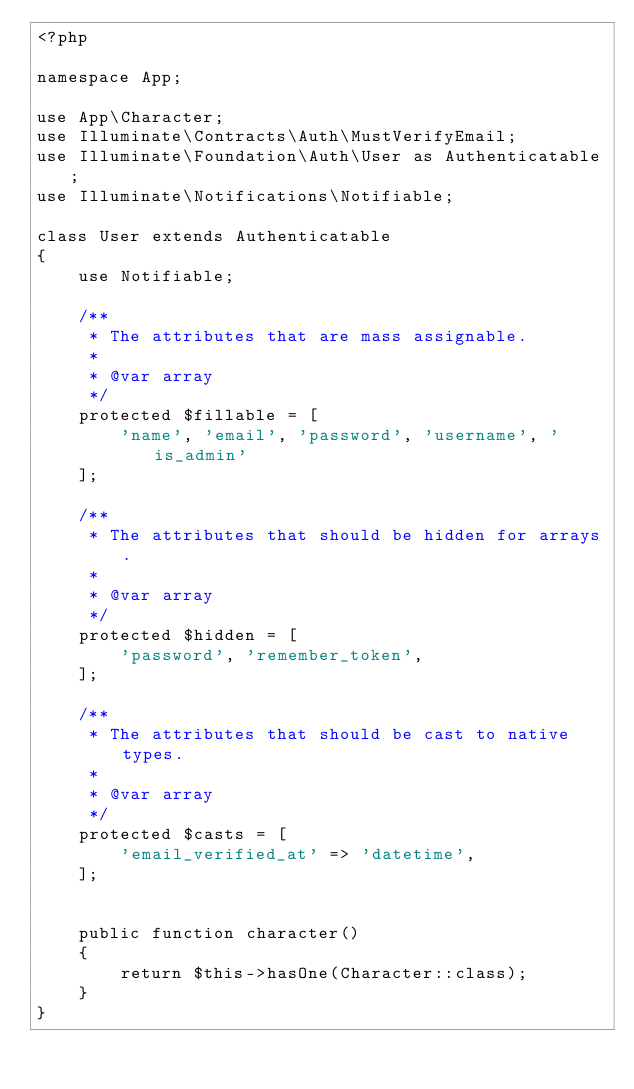Convert code to text. <code><loc_0><loc_0><loc_500><loc_500><_PHP_><?php

namespace App;

use App\Character;
use Illuminate\Contracts\Auth\MustVerifyEmail;
use Illuminate\Foundation\Auth\User as Authenticatable;
use Illuminate\Notifications\Notifiable;

class User extends Authenticatable
{
    use Notifiable;

    /**
     * The attributes that are mass assignable.
     *
     * @var array
     */
    protected $fillable = [
        'name', 'email', 'password', 'username', 'is_admin'
    ];

    /**
     * The attributes that should be hidden for arrays.
     *
     * @var array
     */
    protected $hidden = [
        'password', 'remember_token',
    ];

    /**
     * The attributes that should be cast to native types.
     *
     * @var array
     */
    protected $casts = [
        'email_verified_at' => 'datetime',
    ];


    public function character()
    {
        return $this->hasOne(Character::class);
    }
}
</code> 